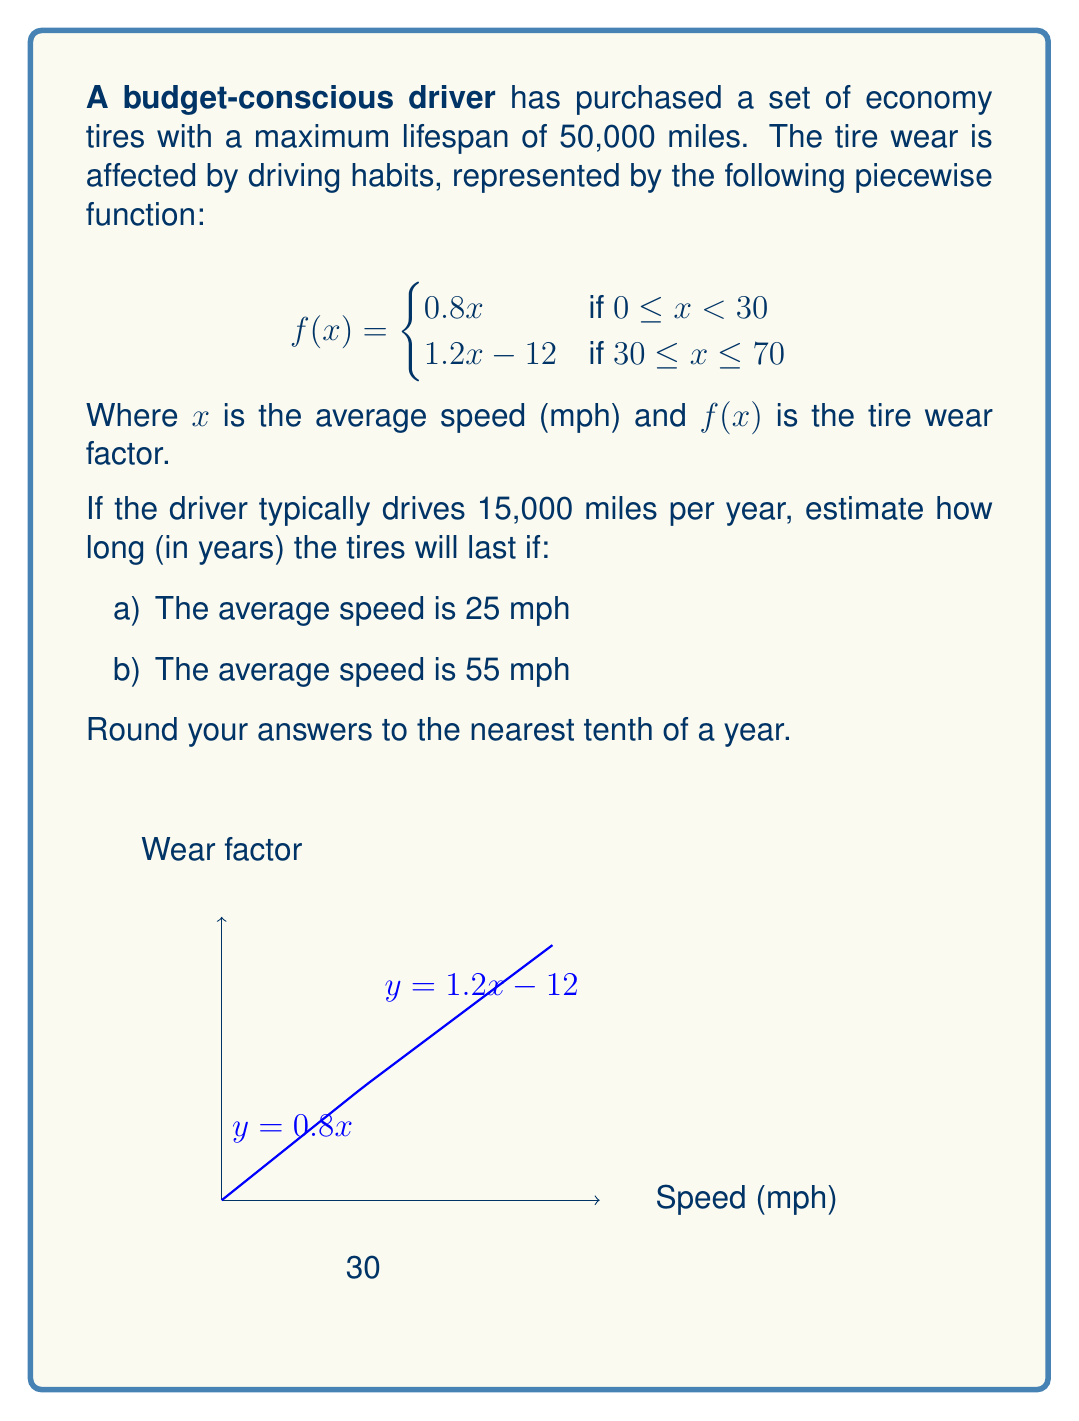Help me with this question. Let's solve this problem step by step:

1) First, we need to calculate the wear factor for each speed:

   a) For 25 mph: $f(25) = 0.8(25) = 20$
   b) For 55 mph: $f(55) = 1.2(55) - 12 = 54$

2) The wear factor tells us how quickly the tires wear out compared to normal conditions. A factor of 1 would be normal wear.

3) To calculate the actual mileage the tires will last:
   Actual mileage = Maximum lifespan / Wear factor

4) For 25 mph:
   Actual mileage = $50,000 / 20 = 2,500$ miles

5) For 55 mph:
   Actual mileage = $50,000 / 54 \approx 926$ miles

6) Now, to calculate how long the tires will last in years:
   Years = Actual mileage / Annual mileage

7) For 25 mph:
   Years = $2,500 / 15,000 \approx 0.1667$ years

8) For 55 mph:
   Years = $926 / 15,000 \approx 0.0617$ years

9) Rounding to the nearest tenth of a year:
   a) 25 mph: 0.2 years
   b) 55 mph: 0.1 years
Answer: a) 0.2 years
b) 0.1 years 